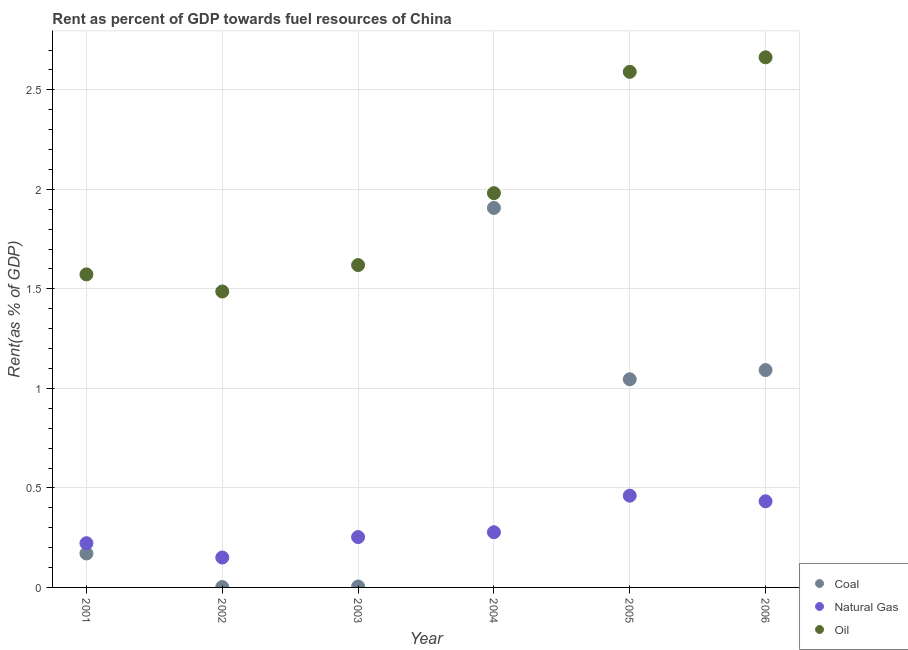Is the number of dotlines equal to the number of legend labels?
Offer a very short reply. Yes. What is the rent towards natural gas in 2006?
Give a very brief answer. 0.43. Across all years, what is the maximum rent towards natural gas?
Give a very brief answer. 0.46. Across all years, what is the minimum rent towards natural gas?
Your answer should be very brief. 0.15. In which year was the rent towards coal maximum?
Offer a very short reply. 2004. In which year was the rent towards natural gas minimum?
Offer a terse response. 2002. What is the total rent towards natural gas in the graph?
Make the answer very short. 1.8. What is the difference between the rent towards oil in 2001 and that in 2004?
Offer a very short reply. -0.41. What is the difference between the rent towards oil in 2002 and the rent towards natural gas in 2005?
Keep it short and to the point. 1.03. What is the average rent towards oil per year?
Provide a short and direct response. 1.99. In the year 2002, what is the difference between the rent towards natural gas and rent towards oil?
Ensure brevity in your answer.  -1.34. What is the ratio of the rent towards coal in 2001 to that in 2003?
Provide a short and direct response. 36.11. Is the rent towards coal in 2001 less than that in 2002?
Ensure brevity in your answer.  No. What is the difference between the highest and the second highest rent towards natural gas?
Provide a succinct answer. 0.03. What is the difference between the highest and the lowest rent towards coal?
Provide a succinct answer. 1.9. Is the rent towards coal strictly greater than the rent towards oil over the years?
Offer a terse response. No. What is the difference between two consecutive major ticks on the Y-axis?
Your answer should be compact. 0.5. Are the values on the major ticks of Y-axis written in scientific E-notation?
Provide a short and direct response. No. What is the title of the graph?
Offer a very short reply. Rent as percent of GDP towards fuel resources of China. Does "Female employers" appear as one of the legend labels in the graph?
Offer a very short reply. No. What is the label or title of the Y-axis?
Offer a very short reply. Rent(as % of GDP). What is the Rent(as % of GDP) of Coal in 2001?
Ensure brevity in your answer.  0.17. What is the Rent(as % of GDP) of Natural Gas in 2001?
Ensure brevity in your answer.  0.22. What is the Rent(as % of GDP) in Oil in 2001?
Make the answer very short. 1.57. What is the Rent(as % of GDP) of Coal in 2002?
Provide a short and direct response. 0. What is the Rent(as % of GDP) in Natural Gas in 2002?
Make the answer very short. 0.15. What is the Rent(as % of GDP) in Oil in 2002?
Keep it short and to the point. 1.49. What is the Rent(as % of GDP) in Coal in 2003?
Keep it short and to the point. 0. What is the Rent(as % of GDP) of Natural Gas in 2003?
Offer a very short reply. 0.25. What is the Rent(as % of GDP) in Oil in 2003?
Make the answer very short. 1.62. What is the Rent(as % of GDP) in Coal in 2004?
Offer a terse response. 1.91. What is the Rent(as % of GDP) of Natural Gas in 2004?
Keep it short and to the point. 0.28. What is the Rent(as % of GDP) of Oil in 2004?
Provide a short and direct response. 1.98. What is the Rent(as % of GDP) of Coal in 2005?
Offer a terse response. 1.05. What is the Rent(as % of GDP) of Natural Gas in 2005?
Ensure brevity in your answer.  0.46. What is the Rent(as % of GDP) of Oil in 2005?
Your answer should be very brief. 2.59. What is the Rent(as % of GDP) of Coal in 2006?
Give a very brief answer. 1.09. What is the Rent(as % of GDP) of Natural Gas in 2006?
Provide a short and direct response. 0.43. What is the Rent(as % of GDP) of Oil in 2006?
Provide a short and direct response. 2.66. Across all years, what is the maximum Rent(as % of GDP) of Coal?
Offer a terse response. 1.91. Across all years, what is the maximum Rent(as % of GDP) in Natural Gas?
Provide a succinct answer. 0.46. Across all years, what is the maximum Rent(as % of GDP) of Oil?
Keep it short and to the point. 2.66. Across all years, what is the minimum Rent(as % of GDP) of Coal?
Offer a very short reply. 0. Across all years, what is the minimum Rent(as % of GDP) in Natural Gas?
Offer a very short reply. 0.15. Across all years, what is the minimum Rent(as % of GDP) in Oil?
Ensure brevity in your answer.  1.49. What is the total Rent(as % of GDP) in Coal in the graph?
Your response must be concise. 4.22. What is the total Rent(as % of GDP) of Natural Gas in the graph?
Make the answer very short. 1.8. What is the total Rent(as % of GDP) in Oil in the graph?
Your response must be concise. 11.91. What is the difference between the Rent(as % of GDP) in Coal in 2001 and that in 2002?
Make the answer very short. 0.17. What is the difference between the Rent(as % of GDP) in Natural Gas in 2001 and that in 2002?
Offer a terse response. 0.07. What is the difference between the Rent(as % of GDP) in Oil in 2001 and that in 2002?
Give a very brief answer. 0.09. What is the difference between the Rent(as % of GDP) in Coal in 2001 and that in 2003?
Provide a short and direct response. 0.17. What is the difference between the Rent(as % of GDP) of Natural Gas in 2001 and that in 2003?
Provide a short and direct response. -0.03. What is the difference between the Rent(as % of GDP) of Oil in 2001 and that in 2003?
Offer a terse response. -0.05. What is the difference between the Rent(as % of GDP) of Coal in 2001 and that in 2004?
Offer a very short reply. -1.74. What is the difference between the Rent(as % of GDP) of Natural Gas in 2001 and that in 2004?
Ensure brevity in your answer.  -0.06. What is the difference between the Rent(as % of GDP) in Oil in 2001 and that in 2004?
Offer a very short reply. -0.41. What is the difference between the Rent(as % of GDP) of Coal in 2001 and that in 2005?
Provide a succinct answer. -0.88. What is the difference between the Rent(as % of GDP) in Natural Gas in 2001 and that in 2005?
Provide a short and direct response. -0.24. What is the difference between the Rent(as % of GDP) in Oil in 2001 and that in 2005?
Your answer should be compact. -1.02. What is the difference between the Rent(as % of GDP) of Coal in 2001 and that in 2006?
Your response must be concise. -0.92. What is the difference between the Rent(as % of GDP) in Natural Gas in 2001 and that in 2006?
Your response must be concise. -0.21. What is the difference between the Rent(as % of GDP) in Oil in 2001 and that in 2006?
Ensure brevity in your answer.  -1.09. What is the difference between the Rent(as % of GDP) of Coal in 2002 and that in 2003?
Your response must be concise. -0. What is the difference between the Rent(as % of GDP) in Natural Gas in 2002 and that in 2003?
Offer a terse response. -0.1. What is the difference between the Rent(as % of GDP) of Oil in 2002 and that in 2003?
Offer a terse response. -0.13. What is the difference between the Rent(as % of GDP) in Coal in 2002 and that in 2004?
Keep it short and to the point. -1.9. What is the difference between the Rent(as % of GDP) in Natural Gas in 2002 and that in 2004?
Your response must be concise. -0.13. What is the difference between the Rent(as % of GDP) in Oil in 2002 and that in 2004?
Provide a succinct answer. -0.49. What is the difference between the Rent(as % of GDP) of Coal in 2002 and that in 2005?
Offer a very short reply. -1.04. What is the difference between the Rent(as % of GDP) in Natural Gas in 2002 and that in 2005?
Ensure brevity in your answer.  -0.31. What is the difference between the Rent(as % of GDP) of Oil in 2002 and that in 2005?
Your answer should be compact. -1.1. What is the difference between the Rent(as % of GDP) of Coal in 2002 and that in 2006?
Offer a very short reply. -1.09. What is the difference between the Rent(as % of GDP) of Natural Gas in 2002 and that in 2006?
Offer a terse response. -0.28. What is the difference between the Rent(as % of GDP) of Oil in 2002 and that in 2006?
Your answer should be compact. -1.18. What is the difference between the Rent(as % of GDP) in Coal in 2003 and that in 2004?
Provide a short and direct response. -1.9. What is the difference between the Rent(as % of GDP) of Natural Gas in 2003 and that in 2004?
Your response must be concise. -0.02. What is the difference between the Rent(as % of GDP) in Oil in 2003 and that in 2004?
Make the answer very short. -0.36. What is the difference between the Rent(as % of GDP) of Coal in 2003 and that in 2005?
Make the answer very short. -1.04. What is the difference between the Rent(as % of GDP) of Natural Gas in 2003 and that in 2005?
Provide a short and direct response. -0.21. What is the difference between the Rent(as % of GDP) in Oil in 2003 and that in 2005?
Your answer should be very brief. -0.97. What is the difference between the Rent(as % of GDP) in Coal in 2003 and that in 2006?
Ensure brevity in your answer.  -1.09. What is the difference between the Rent(as % of GDP) of Natural Gas in 2003 and that in 2006?
Ensure brevity in your answer.  -0.18. What is the difference between the Rent(as % of GDP) of Oil in 2003 and that in 2006?
Your answer should be very brief. -1.04. What is the difference between the Rent(as % of GDP) in Coal in 2004 and that in 2005?
Provide a succinct answer. 0.86. What is the difference between the Rent(as % of GDP) in Natural Gas in 2004 and that in 2005?
Your response must be concise. -0.18. What is the difference between the Rent(as % of GDP) in Oil in 2004 and that in 2005?
Provide a short and direct response. -0.61. What is the difference between the Rent(as % of GDP) in Coal in 2004 and that in 2006?
Your answer should be very brief. 0.81. What is the difference between the Rent(as % of GDP) of Natural Gas in 2004 and that in 2006?
Keep it short and to the point. -0.16. What is the difference between the Rent(as % of GDP) in Oil in 2004 and that in 2006?
Offer a terse response. -0.68. What is the difference between the Rent(as % of GDP) in Coal in 2005 and that in 2006?
Your response must be concise. -0.05. What is the difference between the Rent(as % of GDP) in Natural Gas in 2005 and that in 2006?
Provide a short and direct response. 0.03. What is the difference between the Rent(as % of GDP) of Oil in 2005 and that in 2006?
Give a very brief answer. -0.07. What is the difference between the Rent(as % of GDP) of Coal in 2001 and the Rent(as % of GDP) of Natural Gas in 2002?
Give a very brief answer. 0.02. What is the difference between the Rent(as % of GDP) in Coal in 2001 and the Rent(as % of GDP) in Oil in 2002?
Your answer should be compact. -1.32. What is the difference between the Rent(as % of GDP) of Natural Gas in 2001 and the Rent(as % of GDP) of Oil in 2002?
Offer a terse response. -1.26. What is the difference between the Rent(as % of GDP) of Coal in 2001 and the Rent(as % of GDP) of Natural Gas in 2003?
Ensure brevity in your answer.  -0.08. What is the difference between the Rent(as % of GDP) of Coal in 2001 and the Rent(as % of GDP) of Oil in 2003?
Provide a succinct answer. -1.45. What is the difference between the Rent(as % of GDP) in Natural Gas in 2001 and the Rent(as % of GDP) in Oil in 2003?
Your answer should be compact. -1.4. What is the difference between the Rent(as % of GDP) in Coal in 2001 and the Rent(as % of GDP) in Natural Gas in 2004?
Offer a terse response. -0.11. What is the difference between the Rent(as % of GDP) of Coal in 2001 and the Rent(as % of GDP) of Oil in 2004?
Your answer should be compact. -1.81. What is the difference between the Rent(as % of GDP) in Natural Gas in 2001 and the Rent(as % of GDP) in Oil in 2004?
Offer a very short reply. -1.76. What is the difference between the Rent(as % of GDP) in Coal in 2001 and the Rent(as % of GDP) in Natural Gas in 2005?
Ensure brevity in your answer.  -0.29. What is the difference between the Rent(as % of GDP) in Coal in 2001 and the Rent(as % of GDP) in Oil in 2005?
Give a very brief answer. -2.42. What is the difference between the Rent(as % of GDP) in Natural Gas in 2001 and the Rent(as % of GDP) in Oil in 2005?
Keep it short and to the point. -2.37. What is the difference between the Rent(as % of GDP) of Coal in 2001 and the Rent(as % of GDP) of Natural Gas in 2006?
Ensure brevity in your answer.  -0.26. What is the difference between the Rent(as % of GDP) in Coal in 2001 and the Rent(as % of GDP) in Oil in 2006?
Ensure brevity in your answer.  -2.49. What is the difference between the Rent(as % of GDP) in Natural Gas in 2001 and the Rent(as % of GDP) in Oil in 2006?
Your answer should be compact. -2.44. What is the difference between the Rent(as % of GDP) of Coal in 2002 and the Rent(as % of GDP) of Natural Gas in 2003?
Give a very brief answer. -0.25. What is the difference between the Rent(as % of GDP) in Coal in 2002 and the Rent(as % of GDP) in Oil in 2003?
Provide a short and direct response. -1.62. What is the difference between the Rent(as % of GDP) of Natural Gas in 2002 and the Rent(as % of GDP) of Oil in 2003?
Keep it short and to the point. -1.47. What is the difference between the Rent(as % of GDP) of Coal in 2002 and the Rent(as % of GDP) of Natural Gas in 2004?
Give a very brief answer. -0.28. What is the difference between the Rent(as % of GDP) of Coal in 2002 and the Rent(as % of GDP) of Oil in 2004?
Ensure brevity in your answer.  -1.98. What is the difference between the Rent(as % of GDP) of Natural Gas in 2002 and the Rent(as % of GDP) of Oil in 2004?
Give a very brief answer. -1.83. What is the difference between the Rent(as % of GDP) in Coal in 2002 and the Rent(as % of GDP) in Natural Gas in 2005?
Provide a succinct answer. -0.46. What is the difference between the Rent(as % of GDP) in Coal in 2002 and the Rent(as % of GDP) in Oil in 2005?
Offer a terse response. -2.59. What is the difference between the Rent(as % of GDP) of Natural Gas in 2002 and the Rent(as % of GDP) of Oil in 2005?
Your response must be concise. -2.44. What is the difference between the Rent(as % of GDP) in Coal in 2002 and the Rent(as % of GDP) in Natural Gas in 2006?
Offer a terse response. -0.43. What is the difference between the Rent(as % of GDP) of Coal in 2002 and the Rent(as % of GDP) of Oil in 2006?
Provide a short and direct response. -2.66. What is the difference between the Rent(as % of GDP) in Natural Gas in 2002 and the Rent(as % of GDP) in Oil in 2006?
Offer a very short reply. -2.51. What is the difference between the Rent(as % of GDP) in Coal in 2003 and the Rent(as % of GDP) in Natural Gas in 2004?
Your answer should be very brief. -0.27. What is the difference between the Rent(as % of GDP) of Coal in 2003 and the Rent(as % of GDP) of Oil in 2004?
Your answer should be very brief. -1.98. What is the difference between the Rent(as % of GDP) of Natural Gas in 2003 and the Rent(as % of GDP) of Oil in 2004?
Offer a very short reply. -1.73. What is the difference between the Rent(as % of GDP) of Coal in 2003 and the Rent(as % of GDP) of Natural Gas in 2005?
Make the answer very short. -0.46. What is the difference between the Rent(as % of GDP) of Coal in 2003 and the Rent(as % of GDP) of Oil in 2005?
Ensure brevity in your answer.  -2.59. What is the difference between the Rent(as % of GDP) in Natural Gas in 2003 and the Rent(as % of GDP) in Oil in 2005?
Offer a very short reply. -2.34. What is the difference between the Rent(as % of GDP) in Coal in 2003 and the Rent(as % of GDP) in Natural Gas in 2006?
Give a very brief answer. -0.43. What is the difference between the Rent(as % of GDP) in Coal in 2003 and the Rent(as % of GDP) in Oil in 2006?
Provide a short and direct response. -2.66. What is the difference between the Rent(as % of GDP) in Natural Gas in 2003 and the Rent(as % of GDP) in Oil in 2006?
Offer a very short reply. -2.41. What is the difference between the Rent(as % of GDP) in Coal in 2004 and the Rent(as % of GDP) in Natural Gas in 2005?
Offer a terse response. 1.45. What is the difference between the Rent(as % of GDP) of Coal in 2004 and the Rent(as % of GDP) of Oil in 2005?
Offer a terse response. -0.68. What is the difference between the Rent(as % of GDP) in Natural Gas in 2004 and the Rent(as % of GDP) in Oil in 2005?
Offer a terse response. -2.31. What is the difference between the Rent(as % of GDP) of Coal in 2004 and the Rent(as % of GDP) of Natural Gas in 2006?
Give a very brief answer. 1.47. What is the difference between the Rent(as % of GDP) of Coal in 2004 and the Rent(as % of GDP) of Oil in 2006?
Make the answer very short. -0.76. What is the difference between the Rent(as % of GDP) in Natural Gas in 2004 and the Rent(as % of GDP) in Oil in 2006?
Ensure brevity in your answer.  -2.39. What is the difference between the Rent(as % of GDP) in Coal in 2005 and the Rent(as % of GDP) in Natural Gas in 2006?
Give a very brief answer. 0.61. What is the difference between the Rent(as % of GDP) of Coal in 2005 and the Rent(as % of GDP) of Oil in 2006?
Your answer should be compact. -1.62. What is the difference between the Rent(as % of GDP) in Natural Gas in 2005 and the Rent(as % of GDP) in Oil in 2006?
Your answer should be compact. -2.2. What is the average Rent(as % of GDP) of Coal per year?
Keep it short and to the point. 0.7. What is the average Rent(as % of GDP) of Natural Gas per year?
Provide a short and direct response. 0.3. What is the average Rent(as % of GDP) of Oil per year?
Offer a very short reply. 1.99. In the year 2001, what is the difference between the Rent(as % of GDP) in Coal and Rent(as % of GDP) in Natural Gas?
Your answer should be very brief. -0.05. In the year 2001, what is the difference between the Rent(as % of GDP) in Coal and Rent(as % of GDP) in Oil?
Provide a short and direct response. -1.4. In the year 2001, what is the difference between the Rent(as % of GDP) in Natural Gas and Rent(as % of GDP) in Oil?
Give a very brief answer. -1.35. In the year 2002, what is the difference between the Rent(as % of GDP) of Coal and Rent(as % of GDP) of Natural Gas?
Your answer should be very brief. -0.15. In the year 2002, what is the difference between the Rent(as % of GDP) of Coal and Rent(as % of GDP) of Oil?
Keep it short and to the point. -1.48. In the year 2002, what is the difference between the Rent(as % of GDP) of Natural Gas and Rent(as % of GDP) of Oil?
Give a very brief answer. -1.34. In the year 2003, what is the difference between the Rent(as % of GDP) of Coal and Rent(as % of GDP) of Natural Gas?
Give a very brief answer. -0.25. In the year 2003, what is the difference between the Rent(as % of GDP) of Coal and Rent(as % of GDP) of Oil?
Your answer should be compact. -1.61. In the year 2003, what is the difference between the Rent(as % of GDP) in Natural Gas and Rent(as % of GDP) in Oil?
Provide a succinct answer. -1.37. In the year 2004, what is the difference between the Rent(as % of GDP) in Coal and Rent(as % of GDP) in Natural Gas?
Keep it short and to the point. 1.63. In the year 2004, what is the difference between the Rent(as % of GDP) in Coal and Rent(as % of GDP) in Oil?
Offer a very short reply. -0.07. In the year 2004, what is the difference between the Rent(as % of GDP) of Natural Gas and Rent(as % of GDP) of Oil?
Make the answer very short. -1.7. In the year 2005, what is the difference between the Rent(as % of GDP) of Coal and Rent(as % of GDP) of Natural Gas?
Make the answer very short. 0.58. In the year 2005, what is the difference between the Rent(as % of GDP) in Coal and Rent(as % of GDP) in Oil?
Give a very brief answer. -1.54. In the year 2005, what is the difference between the Rent(as % of GDP) in Natural Gas and Rent(as % of GDP) in Oil?
Offer a very short reply. -2.13. In the year 2006, what is the difference between the Rent(as % of GDP) of Coal and Rent(as % of GDP) of Natural Gas?
Your response must be concise. 0.66. In the year 2006, what is the difference between the Rent(as % of GDP) of Coal and Rent(as % of GDP) of Oil?
Give a very brief answer. -1.57. In the year 2006, what is the difference between the Rent(as % of GDP) in Natural Gas and Rent(as % of GDP) in Oil?
Ensure brevity in your answer.  -2.23. What is the ratio of the Rent(as % of GDP) of Coal in 2001 to that in 2002?
Ensure brevity in your answer.  83.58. What is the ratio of the Rent(as % of GDP) of Natural Gas in 2001 to that in 2002?
Offer a very short reply. 1.48. What is the ratio of the Rent(as % of GDP) of Oil in 2001 to that in 2002?
Give a very brief answer. 1.06. What is the ratio of the Rent(as % of GDP) in Coal in 2001 to that in 2003?
Provide a succinct answer. 36.11. What is the ratio of the Rent(as % of GDP) of Natural Gas in 2001 to that in 2003?
Give a very brief answer. 0.88. What is the ratio of the Rent(as % of GDP) of Oil in 2001 to that in 2003?
Your answer should be compact. 0.97. What is the ratio of the Rent(as % of GDP) of Coal in 2001 to that in 2004?
Your response must be concise. 0.09. What is the ratio of the Rent(as % of GDP) in Natural Gas in 2001 to that in 2004?
Ensure brevity in your answer.  0.8. What is the ratio of the Rent(as % of GDP) in Oil in 2001 to that in 2004?
Offer a terse response. 0.79. What is the ratio of the Rent(as % of GDP) of Coal in 2001 to that in 2005?
Provide a short and direct response. 0.16. What is the ratio of the Rent(as % of GDP) in Natural Gas in 2001 to that in 2005?
Your answer should be compact. 0.48. What is the ratio of the Rent(as % of GDP) in Oil in 2001 to that in 2005?
Give a very brief answer. 0.61. What is the ratio of the Rent(as % of GDP) of Coal in 2001 to that in 2006?
Provide a succinct answer. 0.16. What is the ratio of the Rent(as % of GDP) of Natural Gas in 2001 to that in 2006?
Keep it short and to the point. 0.51. What is the ratio of the Rent(as % of GDP) in Oil in 2001 to that in 2006?
Ensure brevity in your answer.  0.59. What is the ratio of the Rent(as % of GDP) of Coal in 2002 to that in 2003?
Offer a very short reply. 0.43. What is the ratio of the Rent(as % of GDP) in Natural Gas in 2002 to that in 2003?
Give a very brief answer. 0.59. What is the ratio of the Rent(as % of GDP) in Oil in 2002 to that in 2003?
Offer a terse response. 0.92. What is the ratio of the Rent(as % of GDP) in Coal in 2002 to that in 2004?
Make the answer very short. 0. What is the ratio of the Rent(as % of GDP) in Natural Gas in 2002 to that in 2004?
Give a very brief answer. 0.54. What is the ratio of the Rent(as % of GDP) in Oil in 2002 to that in 2004?
Your answer should be compact. 0.75. What is the ratio of the Rent(as % of GDP) of Coal in 2002 to that in 2005?
Offer a very short reply. 0. What is the ratio of the Rent(as % of GDP) in Natural Gas in 2002 to that in 2005?
Give a very brief answer. 0.33. What is the ratio of the Rent(as % of GDP) of Oil in 2002 to that in 2005?
Keep it short and to the point. 0.57. What is the ratio of the Rent(as % of GDP) of Coal in 2002 to that in 2006?
Provide a succinct answer. 0. What is the ratio of the Rent(as % of GDP) of Natural Gas in 2002 to that in 2006?
Provide a short and direct response. 0.35. What is the ratio of the Rent(as % of GDP) of Oil in 2002 to that in 2006?
Give a very brief answer. 0.56. What is the ratio of the Rent(as % of GDP) of Coal in 2003 to that in 2004?
Your answer should be very brief. 0. What is the ratio of the Rent(as % of GDP) of Natural Gas in 2003 to that in 2004?
Ensure brevity in your answer.  0.91. What is the ratio of the Rent(as % of GDP) of Oil in 2003 to that in 2004?
Keep it short and to the point. 0.82. What is the ratio of the Rent(as % of GDP) in Coal in 2003 to that in 2005?
Give a very brief answer. 0. What is the ratio of the Rent(as % of GDP) in Natural Gas in 2003 to that in 2005?
Provide a short and direct response. 0.55. What is the ratio of the Rent(as % of GDP) of Oil in 2003 to that in 2005?
Your answer should be very brief. 0.63. What is the ratio of the Rent(as % of GDP) in Coal in 2003 to that in 2006?
Provide a succinct answer. 0. What is the ratio of the Rent(as % of GDP) of Natural Gas in 2003 to that in 2006?
Provide a short and direct response. 0.58. What is the ratio of the Rent(as % of GDP) of Oil in 2003 to that in 2006?
Keep it short and to the point. 0.61. What is the ratio of the Rent(as % of GDP) of Coal in 2004 to that in 2005?
Offer a terse response. 1.82. What is the ratio of the Rent(as % of GDP) in Natural Gas in 2004 to that in 2005?
Offer a very short reply. 0.6. What is the ratio of the Rent(as % of GDP) of Oil in 2004 to that in 2005?
Make the answer very short. 0.76. What is the ratio of the Rent(as % of GDP) in Coal in 2004 to that in 2006?
Your response must be concise. 1.75. What is the ratio of the Rent(as % of GDP) in Natural Gas in 2004 to that in 2006?
Offer a terse response. 0.64. What is the ratio of the Rent(as % of GDP) in Oil in 2004 to that in 2006?
Offer a very short reply. 0.74. What is the ratio of the Rent(as % of GDP) in Coal in 2005 to that in 2006?
Offer a very short reply. 0.96. What is the ratio of the Rent(as % of GDP) of Natural Gas in 2005 to that in 2006?
Provide a short and direct response. 1.06. What is the ratio of the Rent(as % of GDP) in Oil in 2005 to that in 2006?
Your response must be concise. 0.97. What is the difference between the highest and the second highest Rent(as % of GDP) of Coal?
Provide a short and direct response. 0.81. What is the difference between the highest and the second highest Rent(as % of GDP) of Natural Gas?
Your response must be concise. 0.03. What is the difference between the highest and the second highest Rent(as % of GDP) of Oil?
Your response must be concise. 0.07. What is the difference between the highest and the lowest Rent(as % of GDP) of Coal?
Provide a succinct answer. 1.9. What is the difference between the highest and the lowest Rent(as % of GDP) of Natural Gas?
Give a very brief answer. 0.31. What is the difference between the highest and the lowest Rent(as % of GDP) of Oil?
Offer a very short reply. 1.18. 